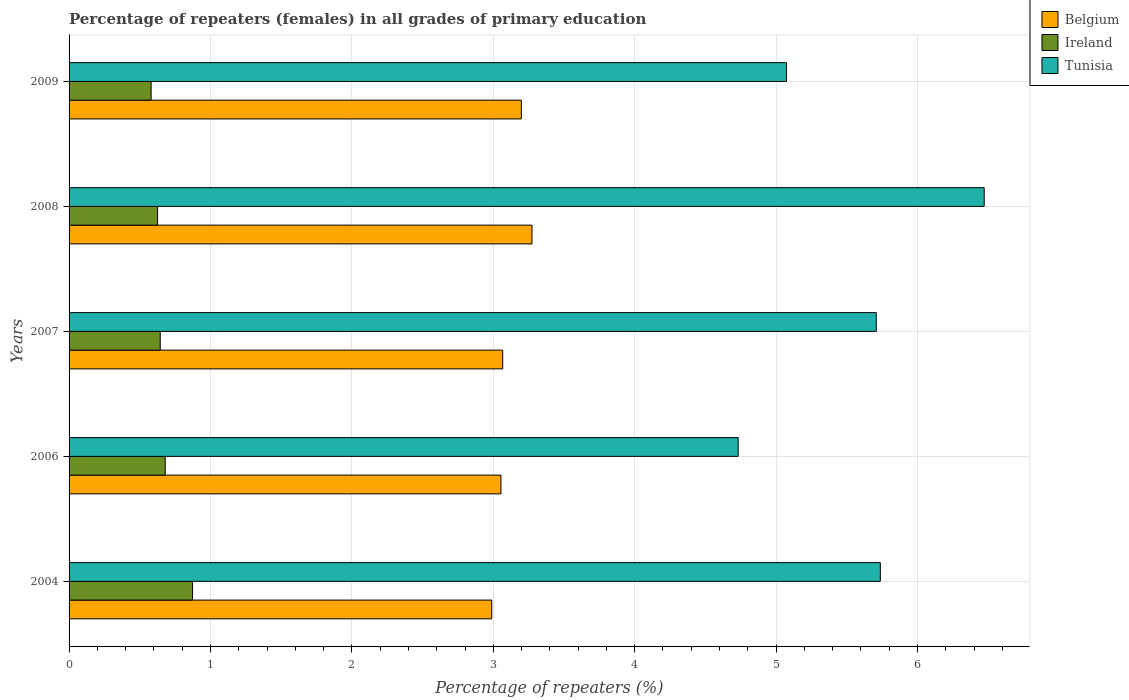Are the number of bars on each tick of the Y-axis equal?
Keep it short and to the point. Yes. How many bars are there on the 4th tick from the bottom?
Offer a terse response. 3. In how many cases, is the number of bars for a given year not equal to the number of legend labels?
Keep it short and to the point. 0. What is the percentage of repeaters (females) in Tunisia in 2009?
Your answer should be very brief. 5.07. Across all years, what is the maximum percentage of repeaters (females) in Ireland?
Ensure brevity in your answer.  0.87. Across all years, what is the minimum percentage of repeaters (females) in Tunisia?
Offer a very short reply. 4.73. What is the total percentage of repeaters (females) in Belgium in the graph?
Your answer should be compact. 15.58. What is the difference between the percentage of repeaters (females) in Tunisia in 2006 and that in 2009?
Give a very brief answer. -0.34. What is the difference between the percentage of repeaters (females) in Ireland in 2004 and the percentage of repeaters (females) in Belgium in 2008?
Offer a terse response. -2.4. What is the average percentage of repeaters (females) in Ireland per year?
Give a very brief answer. 0.68. In the year 2004, what is the difference between the percentage of repeaters (females) in Tunisia and percentage of repeaters (females) in Ireland?
Keep it short and to the point. 4.86. What is the ratio of the percentage of repeaters (females) in Tunisia in 2004 to that in 2009?
Give a very brief answer. 1.13. Is the difference between the percentage of repeaters (females) in Tunisia in 2004 and 2009 greater than the difference between the percentage of repeaters (females) in Ireland in 2004 and 2009?
Ensure brevity in your answer.  Yes. What is the difference between the highest and the second highest percentage of repeaters (females) in Ireland?
Ensure brevity in your answer.  0.19. What is the difference between the highest and the lowest percentage of repeaters (females) in Ireland?
Your answer should be very brief. 0.29. Is the sum of the percentage of repeaters (females) in Ireland in 2008 and 2009 greater than the maximum percentage of repeaters (females) in Tunisia across all years?
Provide a succinct answer. No. What does the 3rd bar from the top in 2007 represents?
Provide a succinct answer. Belgium. Is it the case that in every year, the sum of the percentage of repeaters (females) in Tunisia and percentage of repeaters (females) in Belgium is greater than the percentage of repeaters (females) in Ireland?
Provide a short and direct response. Yes. How many bars are there?
Make the answer very short. 15. Are all the bars in the graph horizontal?
Your answer should be compact. Yes. How many years are there in the graph?
Give a very brief answer. 5. What is the difference between two consecutive major ticks on the X-axis?
Ensure brevity in your answer.  1. Are the values on the major ticks of X-axis written in scientific E-notation?
Ensure brevity in your answer.  No. Does the graph contain grids?
Make the answer very short. Yes. How many legend labels are there?
Your answer should be very brief. 3. How are the legend labels stacked?
Give a very brief answer. Vertical. What is the title of the graph?
Your response must be concise. Percentage of repeaters (females) in all grades of primary education. Does "Samoa" appear as one of the legend labels in the graph?
Your response must be concise. No. What is the label or title of the X-axis?
Offer a very short reply. Percentage of repeaters (%). What is the label or title of the Y-axis?
Keep it short and to the point. Years. What is the Percentage of repeaters (%) of Belgium in 2004?
Ensure brevity in your answer.  2.99. What is the Percentage of repeaters (%) in Ireland in 2004?
Make the answer very short. 0.87. What is the Percentage of repeaters (%) in Tunisia in 2004?
Offer a very short reply. 5.74. What is the Percentage of repeaters (%) in Belgium in 2006?
Offer a very short reply. 3.05. What is the Percentage of repeaters (%) in Ireland in 2006?
Offer a terse response. 0.68. What is the Percentage of repeaters (%) of Tunisia in 2006?
Your response must be concise. 4.73. What is the Percentage of repeaters (%) of Belgium in 2007?
Give a very brief answer. 3.07. What is the Percentage of repeaters (%) of Ireland in 2007?
Your answer should be compact. 0.64. What is the Percentage of repeaters (%) of Tunisia in 2007?
Your response must be concise. 5.71. What is the Percentage of repeaters (%) in Belgium in 2008?
Keep it short and to the point. 3.27. What is the Percentage of repeaters (%) in Ireland in 2008?
Make the answer very short. 0.63. What is the Percentage of repeaters (%) of Tunisia in 2008?
Give a very brief answer. 6.47. What is the Percentage of repeaters (%) in Belgium in 2009?
Give a very brief answer. 3.2. What is the Percentage of repeaters (%) in Ireland in 2009?
Ensure brevity in your answer.  0.58. What is the Percentage of repeaters (%) of Tunisia in 2009?
Your answer should be very brief. 5.07. Across all years, what is the maximum Percentage of repeaters (%) in Belgium?
Your answer should be compact. 3.27. Across all years, what is the maximum Percentage of repeaters (%) of Ireland?
Offer a very short reply. 0.87. Across all years, what is the maximum Percentage of repeaters (%) of Tunisia?
Keep it short and to the point. 6.47. Across all years, what is the minimum Percentage of repeaters (%) in Belgium?
Make the answer very short. 2.99. Across all years, what is the minimum Percentage of repeaters (%) of Ireland?
Your answer should be very brief. 0.58. Across all years, what is the minimum Percentage of repeaters (%) of Tunisia?
Ensure brevity in your answer.  4.73. What is the total Percentage of repeaters (%) in Belgium in the graph?
Give a very brief answer. 15.58. What is the total Percentage of repeaters (%) of Ireland in the graph?
Offer a terse response. 3.4. What is the total Percentage of repeaters (%) of Tunisia in the graph?
Provide a short and direct response. 27.72. What is the difference between the Percentage of repeaters (%) in Belgium in 2004 and that in 2006?
Offer a very short reply. -0.07. What is the difference between the Percentage of repeaters (%) in Ireland in 2004 and that in 2006?
Offer a very short reply. 0.19. What is the difference between the Percentage of repeaters (%) of Belgium in 2004 and that in 2007?
Offer a very short reply. -0.08. What is the difference between the Percentage of repeaters (%) of Ireland in 2004 and that in 2007?
Your answer should be compact. 0.23. What is the difference between the Percentage of repeaters (%) in Tunisia in 2004 and that in 2007?
Give a very brief answer. 0.03. What is the difference between the Percentage of repeaters (%) of Belgium in 2004 and that in 2008?
Your answer should be compact. -0.28. What is the difference between the Percentage of repeaters (%) in Ireland in 2004 and that in 2008?
Provide a succinct answer. 0.25. What is the difference between the Percentage of repeaters (%) in Tunisia in 2004 and that in 2008?
Provide a short and direct response. -0.73. What is the difference between the Percentage of repeaters (%) of Belgium in 2004 and that in 2009?
Your response must be concise. -0.21. What is the difference between the Percentage of repeaters (%) of Ireland in 2004 and that in 2009?
Keep it short and to the point. 0.29. What is the difference between the Percentage of repeaters (%) of Tunisia in 2004 and that in 2009?
Offer a terse response. 0.66. What is the difference between the Percentage of repeaters (%) of Belgium in 2006 and that in 2007?
Your response must be concise. -0.01. What is the difference between the Percentage of repeaters (%) in Ireland in 2006 and that in 2007?
Keep it short and to the point. 0.04. What is the difference between the Percentage of repeaters (%) of Tunisia in 2006 and that in 2007?
Give a very brief answer. -0.98. What is the difference between the Percentage of repeaters (%) in Belgium in 2006 and that in 2008?
Your answer should be compact. -0.22. What is the difference between the Percentage of repeaters (%) in Ireland in 2006 and that in 2008?
Provide a short and direct response. 0.05. What is the difference between the Percentage of repeaters (%) of Tunisia in 2006 and that in 2008?
Give a very brief answer. -1.74. What is the difference between the Percentage of repeaters (%) in Belgium in 2006 and that in 2009?
Keep it short and to the point. -0.14. What is the difference between the Percentage of repeaters (%) of Ireland in 2006 and that in 2009?
Provide a short and direct response. 0.1. What is the difference between the Percentage of repeaters (%) in Tunisia in 2006 and that in 2009?
Offer a very short reply. -0.34. What is the difference between the Percentage of repeaters (%) of Belgium in 2007 and that in 2008?
Keep it short and to the point. -0.21. What is the difference between the Percentage of repeaters (%) in Ireland in 2007 and that in 2008?
Make the answer very short. 0.02. What is the difference between the Percentage of repeaters (%) of Tunisia in 2007 and that in 2008?
Offer a very short reply. -0.76. What is the difference between the Percentage of repeaters (%) of Belgium in 2007 and that in 2009?
Make the answer very short. -0.13. What is the difference between the Percentage of repeaters (%) in Ireland in 2007 and that in 2009?
Keep it short and to the point. 0.06. What is the difference between the Percentage of repeaters (%) of Tunisia in 2007 and that in 2009?
Your answer should be very brief. 0.63. What is the difference between the Percentage of repeaters (%) of Belgium in 2008 and that in 2009?
Offer a very short reply. 0.08. What is the difference between the Percentage of repeaters (%) of Ireland in 2008 and that in 2009?
Your answer should be compact. 0.05. What is the difference between the Percentage of repeaters (%) of Tunisia in 2008 and that in 2009?
Your answer should be very brief. 1.4. What is the difference between the Percentage of repeaters (%) of Belgium in 2004 and the Percentage of repeaters (%) of Ireland in 2006?
Keep it short and to the point. 2.31. What is the difference between the Percentage of repeaters (%) in Belgium in 2004 and the Percentage of repeaters (%) in Tunisia in 2006?
Offer a terse response. -1.74. What is the difference between the Percentage of repeaters (%) of Ireland in 2004 and the Percentage of repeaters (%) of Tunisia in 2006?
Your answer should be very brief. -3.86. What is the difference between the Percentage of repeaters (%) in Belgium in 2004 and the Percentage of repeaters (%) in Ireland in 2007?
Make the answer very short. 2.34. What is the difference between the Percentage of repeaters (%) in Belgium in 2004 and the Percentage of repeaters (%) in Tunisia in 2007?
Your response must be concise. -2.72. What is the difference between the Percentage of repeaters (%) of Ireland in 2004 and the Percentage of repeaters (%) of Tunisia in 2007?
Provide a short and direct response. -4.84. What is the difference between the Percentage of repeaters (%) of Belgium in 2004 and the Percentage of repeaters (%) of Ireland in 2008?
Offer a very short reply. 2.36. What is the difference between the Percentage of repeaters (%) in Belgium in 2004 and the Percentage of repeaters (%) in Tunisia in 2008?
Keep it short and to the point. -3.48. What is the difference between the Percentage of repeaters (%) of Ireland in 2004 and the Percentage of repeaters (%) of Tunisia in 2008?
Your answer should be very brief. -5.6. What is the difference between the Percentage of repeaters (%) in Belgium in 2004 and the Percentage of repeaters (%) in Ireland in 2009?
Your answer should be very brief. 2.41. What is the difference between the Percentage of repeaters (%) in Belgium in 2004 and the Percentage of repeaters (%) in Tunisia in 2009?
Provide a short and direct response. -2.08. What is the difference between the Percentage of repeaters (%) of Ireland in 2004 and the Percentage of repeaters (%) of Tunisia in 2009?
Give a very brief answer. -4.2. What is the difference between the Percentage of repeaters (%) in Belgium in 2006 and the Percentage of repeaters (%) in Ireland in 2007?
Offer a terse response. 2.41. What is the difference between the Percentage of repeaters (%) in Belgium in 2006 and the Percentage of repeaters (%) in Tunisia in 2007?
Your answer should be very brief. -2.65. What is the difference between the Percentage of repeaters (%) of Ireland in 2006 and the Percentage of repeaters (%) of Tunisia in 2007?
Keep it short and to the point. -5.03. What is the difference between the Percentage of repeaters (%) in Belgium in 2006 and the Percentage of repeaters (%) in Ireland in 2008?
Make the answer very short. 2.43. What is the difference between the Percentage of repeaters (%) in Belgium in 2006 and the Percentage of repeaters (%) in Tunisia in 2008?
Offer a terse response. -3.42. What is the difference between the Percentage of repeaters (%) in Ireland in 2006 and the Percentage of repeaters (%) in Tunisia in 2008?
Your response must be concise. -5.79. What is the difference between the Percentage of repeaters (%) of Belgium in 2006 and the Percentage of repeaters (%) of Ireland in 2009?
Provide a succinct answer. 2.47. What is the difference between the Percentage of repeaters (%) of Belgium in 2006 and the Percentage of repeaters (%) of Tunisia in 2009?
Offer a very short reply. -2.02. What is the difference between the Percentage of repeaters (%) of Ireland in 2006 and the Percentage of repeaters (%) of Tunisia in 2009?
Give a very brief answer. -4.39. What is the difference between the Percentage of repeaters (%) in Belgium in 2007 and the Percentage of repeaters (%) in Ireland in 2008?
Keep it short and to the point. 2.44. What is the difference between the Percentage of repeaters (%) in Belgium in 2007 and the Percentage of repeaters (%) in Tunisia in 2008?
Provide a succinct answer. -3.41. What is the difference between the Percentage of repeaters (%) in Ireland in 2007 and the Percentage of repeaters (%) in Tunisia in 2008?
Ensure brevity in your answer.  -5.83. What is the difference between the Percentage of repeaters (%) of Belgium in 2007 and the Percentage of repeaters (%) of Ireland in 2009?
Your answer should be compact. 2.49. What is the difference between the Percentage of repeaters (%) of Belgium in 2007 and the Percentage of repeaters (%) of Tunisia in 2009?
Offer a terse response. -2.01. What is the difference between the Percentage of repeaters (%) of Ireland in 2007 and the Percentage of repeaters (%) of Tunisia in 2009?
Ensure brevity in your answer.  -4.43. What is the difference between the Percentage of repeaters (%) of Belgium in 2008 and the Percentage of repeaters (%) of Ireland in 2009?
Keep it short and to the point. 2.69. What is the difference between the Percentage of repeaters (%) in Belgium in 2008 and the Percentage of repeaters (%) in Tunisia in 2009?
Offer a very short reply. -1.8. What is the difference between the Percentage of repeaters (%) in Ireland in 2008 and the Percentage of repeaters (%) in Tunisia in 2009?
Give a very brief answer. -4.45. What is the average Percentage of repeaters (%) of Belgium per year?
Make the answer very short. 3.12. What is the average Percentage of repeaters (%) of Ireland per year?
Provide a short and direct response. 0.68. What is the average Percentage of repeaters (%) in Tunisia per year?
Your answer should be very brief. 5.54. In the year 2004, what is the difference between the Percentage of repeaters (%) in Belgium and Percentage of repeaters (%) in Ireland?
Give a very brief answer. 2.12. In the year 2004, what is the difference between the Percentage of repeaters (%) in Belgium and Percentage of repeaters (%) in Tunisia?
Provide a short and direct response. -2.75. In the year 2004, what is the difference between the Percentage of repeaters (%) of Ireland and Percentage of repeaters (%) of Tunisia?
Your answer should be compact. -4.86. In the year 2006, what is the difference between the Percentage of repeaters (%) of Belgium and Percentage of repeaters (%) of Ireland?
Ensure brevity in your answer.  2.37. In the year 2006, what is the difference between the Percentage of repeaters (%) in Belgium and Percentage of repeaters (%) in Tunisia?
Keep it short and to the point. -1.68. In the year 2006, what is the difference between the Percentage of repeaters (%) of Ireland and Percentage of repeaters (%) of Tunisia?
Offer a very short reply. -4.05. In the year 2007, what is the difference between the Percentage of repeaters (%) of Belgium and Percentage of repeaters (%) of Ireland?
Offer a very short reply. 2.42. In the year 2007, what is the difference between the Percentage of repeaters (%) of Belgium and Percentage of repeaters (%) of Tunisia?
Ensure brevity in your answer.  -2.64. In the year 2007, what is the difference between the Percentage of repeaters (%) of Ireland and Percentage of repeaters (%) of Tunisia?
Offer a terse response. -5.06. In the year 2008, what is the difference between the Percentage of repeaters (%) in Belgium and Percentage of repeaters (%) in Ireland?
Give a very brief answer. 2.65. In the year 2008, what is the difference between the Percentage of repeaters (%) in Belgium and Percentage of repeaters (%) in Tunisia?
Provide a short and direct response. -3.2. In the year 2008, what is the difference between the Percentage of repeaters (%) of Ireland and Percentage of repeaters (%) of Tunisia?
Offer a very short reply. -5.85. In the year 2009, what is the difference between the Percentage of repeaters (%) in Belgium and Percentage of repeaters (%) in Ireland?
Your answer should be compact. 2.62. In the year 2009, what is the difference between the Percentage of repeaters (%) in Belgium and Percentage of repeaters (%) in Tunisia?
Offer a very short reply. -1.88. In the year 2009, what is the difference between the Percentage of repeaters (%) of Ireland and Percentage of repeaters (%) of Tunisia?
Your answer should be very brief. -4.49. What is the ratio of the Percentage of repeaters (%) in Belgium in 2004 to that in 2006?
Make the answer very short. 0.98. What is the ratio of the Percentage of repeaters (%) in Ireland in 2004 to that in 2006?
Make the answer very short. 1.28. What is the ratio of the Percentage of repeaters (%) in Tunisia in 2004 to that in 2006?
Your response must be concise. 1.21. What is the ratio of the Percentage of repeaters (%) of Belgium in 2004 to that in 2007?
Give a very brief answer. 0.97. What is the ratio of the Percentage of repeaters (%) of Ireland in 2004 to that in 2007?
Offer a terse response. 1.35. What is the ratio of the Percentage of repeaters (%) in Belgium in 2004 to that in 2008?
Provide a succinct answer. 0.91. What is the ratio of the Percentage of repeaters (%) of Ireland in 2004 to that in 2008?
Provide a succinct answer. 1.39. What is the ratio of the Percentage of repeaters (%) of Tunisia in 2004 to that in 2008?
Your answer should be compact. 0.89. What is the ratio of the Percentage of repeaters (%) in Belgium in 2004 to that in 2009?
Your answer should be very brief. 0.93. What is the ratio of the Percentage of repeaters (%) in Ireland in 2004 to that in 2009?
Provide a short and direct response. 1.51. What is the ratio of the Percentage of repeaters (%) of Tunisia in 2004 to that in 2009?
Ensure brevity in your answer.  1.13. What is the ratio of the Percentage of repeaters (%) in Belgium in 2006 to that in 2007?
Give a very brief answer. 1. What is the ratio of the Percentage of repeaters (%) in Ireland in 2006 to that in 2007?
Provide a short and direct response. 1.05. What is the ratio of the Percentage of repeaters (%) of Tunisia in 2006 to that in 2007?
Your answer should be compact. 0.83. What is the ratio of the Percentage of repeaters (%) of Belgium in 2006 to that in 2008?
Your answer should be very brief. 0.93. What is the ratio of the Percentage of repeaters (%) of Ireland in 2006 to that in 2008?
Your answer should be compact. 1.09. What is the ratio of the Percentage of repeaters (%) of Tunisia in 2006 to that in 2008?
Your answer should be compact. 0.73. What is the ratio of the Percentage of repeaters (%) in Belgium in 2006 to that in 2009?
Offer a very short reply. 0.95. What is the ratio of the Percentage of repeaters (%) in Ireland in 2006 to that in 2009?
Give a very brief answer. 1.17. What is the ratio of the Percentage of repeaters (%) of Tunisia in 2006 to that in 2009?
Keep it short and to the point. 0.93. What is the ratio of the Percentage of repeaters (%) of Belgium in 2007 to that in 2008?
Your answer should be very brief. 0.94. What is the ratio of the Percentage of repeaters (%) in Ireland in 2007 to that in 2008?
Keep it short and to the point. 1.03. What is the ratio of the Percentage of repeaters (%) of Tunisia in 2007 to that in 2008?
Offer a terse response. 0.88. What is the ratio of the Percentage of repeaters (%) in Belgium in 2007 to that in 2009?
Make the answer very short. 0.96. What is the ratio of the Percentage of repeaters (%) of Ireland in 2007 to that in 2009?
Make the answer very short. 1.11. What is the ratio of the Percentage of repeaters (%) of Tunisia in 2007 to that in 2009?
Provide a short and direct response. 1.13. What is the ratio of the Percentage of repeaters (%) in Belgium in 2008 to that in 2009?
Keep it short and to the point. 1.02. What is the ratio of the Percentage of repeaters (%) in Ireland in 2008 to that in 2009?
Your response must be concise. 1.08. What is the ratio of the Percentage of repeaters (%) in Tunisia in 2008 to that in 2009?
Your response must be concise. 1.28. What is the difference between the highest and the second highest Percentage of repeaters (%) in Belgium?
Keep it short and to the point. 0.08. What is the difference between the highest and the second highest Percentage of repeaters (%) in Ireland?
Your answer should be compact. 0.19. What is the difference between the highest and the second highest Percentage of repeaters (%) of Tunisia?
Offer a terse response. 0.73. What is the difference between the highest and the lowest Percentage of repeaters (%) of Belgium?
Give a very brief answer. 0.28. What is the difference between the highest and the lowest Percentage of repeaters (%) of Ireland?
Provide a succinct answer. 0.29. What is the difference between the highest and the lowest Percentage of repeaters (%) in Tunisia?
Give a very brief answer. 1.74. 